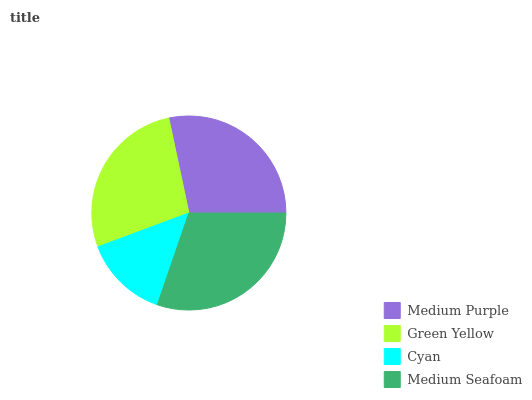Is Cyan the minimum?
Answer yes or no. Yes. Is Medium Seafoam the maximum?
Answer yes or no. Yes. Is Green Yellow the minimum?
Answer yes or no. No. Is Green Yellow the maximum?
Answer yes or no. No. Is Medium Purple greater than Green Yellow?
Answer yes or no. Yes. Is Green Yellow less than Medium Purple?
Answer yes or no. Yes. Is Green Yellow greater than Medium Purple?
Answer yes or no. No. Is Medium Purple less than Green Yellow?
Answer yes or no. No. Is Medium Purple the high median?
Answer yes or no. Yes. Is Green Yellow the low median?
Answer yes or no. Yes. Is Green Yellow the high median?
Answer yes or no. No. Is Medium Purple the low median?
Answer yes or no. No. 